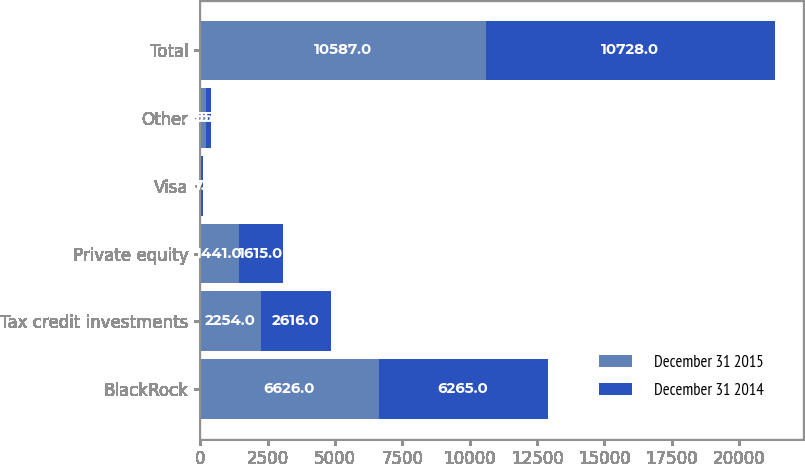Convert chart. <chart><loc_0><loc_0><loc_500><loc_500><stacked_bar_chart><ecel><fcel>BlackRock<fcel>Tax credit investments<fcel>Private equity<fcel>Visa<fcel>Other<fcel>Total<nl><fcel>December 31 2015<fcel>6626<fcel>2254<fcel>1441<fcel>31<fcel>235<fcel>10587<nl><fcel>December 31 2014<fcel>6265<fcel>2616<fcel>1615<fcel>77<fcel>155<fcel>10728<nl></chart> 